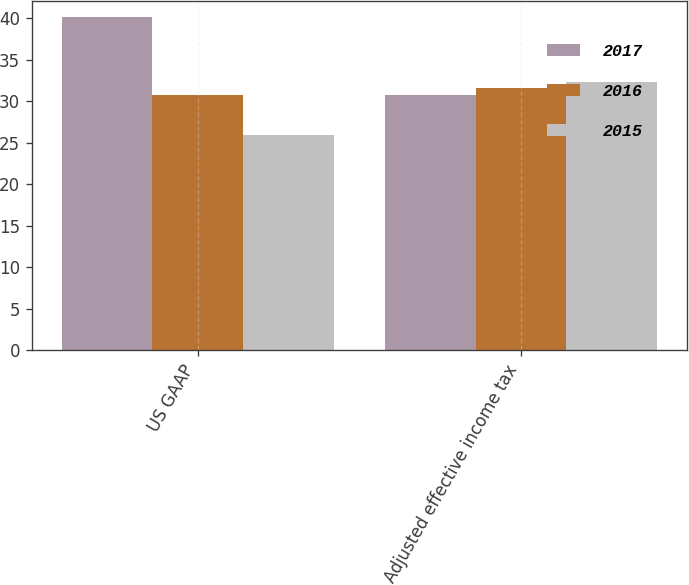Convert chart. <chart><loc_0><loc_0><loc_500><loc_500><stacked_bar_chart><ecel><fcel>US GAAP<fcel>Adjusted effective income tax<nl><fcel>2017<fcel>40.1<fcel>30.8<nl><fcel>2016<fcel>30.8<fcel>31.6<nl><fcel>2015<fcel>25.9<fcel>32.3<nl></chart> 